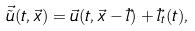<formula> <loc_0><loc_0><loc_500><loc_500>\vec { \tilde { u } } ( t , \vec { x } ) = \vec { u } ( t , \vec { x } - \vec { l } ) + \vec { l } _ { t } ( t ) ,</formula> 